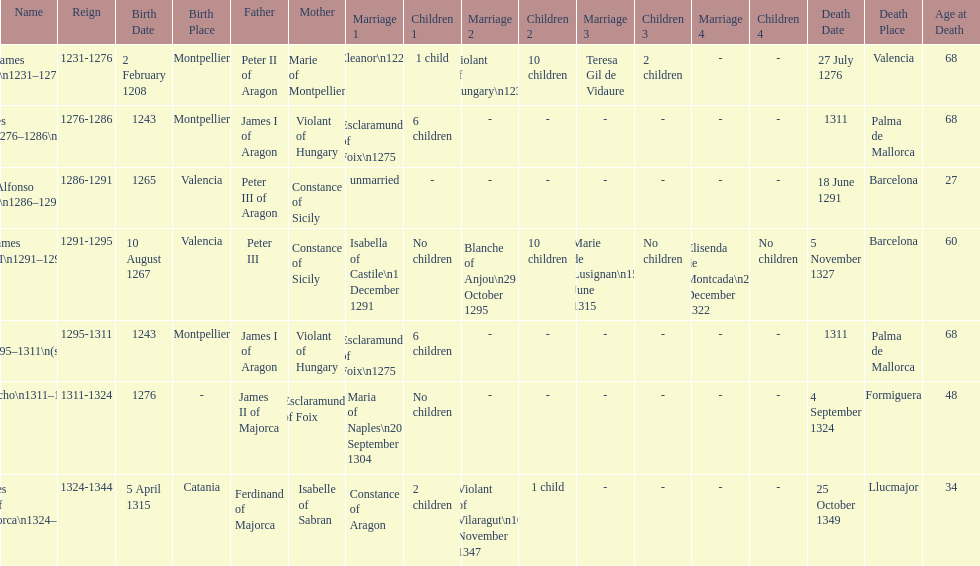Which monarch had the most marriages? James III 1291-1295. 